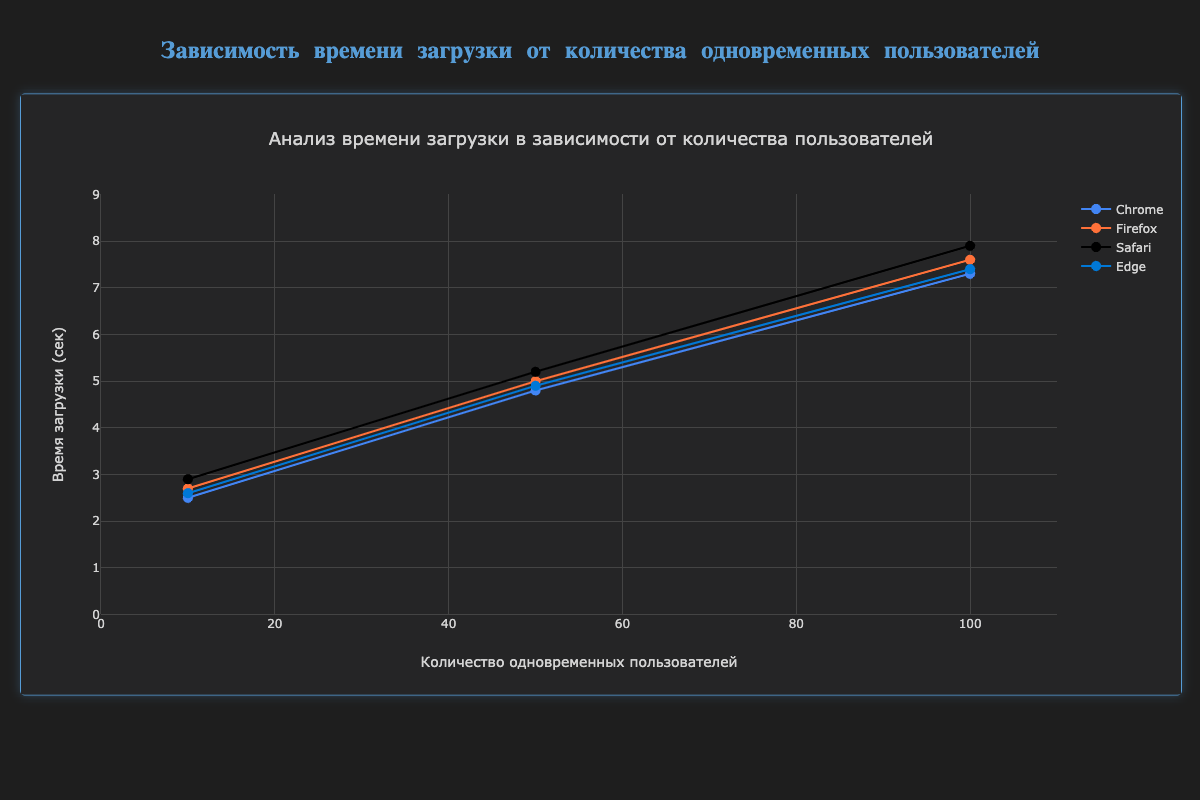What's the title of the chart? The title of the chart is at the top and it reads "Анализ времени загрузки в зависимости от количества пользователей", which translates to "Analysis of Load Time Depending on the Number of Users".
Answer: Анализ времени загрузки в зависимости от количества пользователей What are the ranges of the x-axis and y-axis? The x-axis ranges from 0 to 110, and the y-axis ranges from 0 to 9, as indicated by the axis labels and ticks on the chart.
Answer: 0 to 110 (x-axis), 0 to 9 (y-axis) Which browser has the highest load time when there are 50 concurrent users? The plot shows four lines, each representing Chrome, Firefox, Safari, and Edge. For 50 concurrent users, Safari's load time is at 5.2 seconds, which is the highest compared to Chrome (4.8s), Firefox (5.0s), and Edge (4.9s).
Answer: Safari What is the average load time for Edge across all user levels? Edge has load times of 2.6s, 4.9s, and 7.4s for 10, 50, and 100 concurrent users, respectively. Calculate the average: (2.6 + 4.9 + 7.4) / 3 = 14.9 / 3 ≈ 4.97 seconds.
Answer: 4.97 seconds Compare the increase in load time for Chrome and Firefox as the number of users increases from 10 to 100. Which browser shows a greater increase? For Chrome, the load time increases from 2.5s to 7.3s, an increase of 4.8s. For Firefox, it increases from 2.7s to 7.6s, an increase of 4.9s. Therefore, Firefox shows a greater increase.
Answer: Firefox What is the overall trend observed in the load times as the number of concurrent users increases? The trend line for each browser indicates that load times increase as the number of concurrent users increases, showing a positive correlation.
Answer: Load times increase Name the browser that shows the least load time for 100 concurrent users. The data points for 100 concurrent users show that Chrome has a load time of 7.3s, Firefox 7.6s, Safari 7.9s, and Edge 7.4s. Therefore, Chrome has the least load time.
Answer: Chrome 